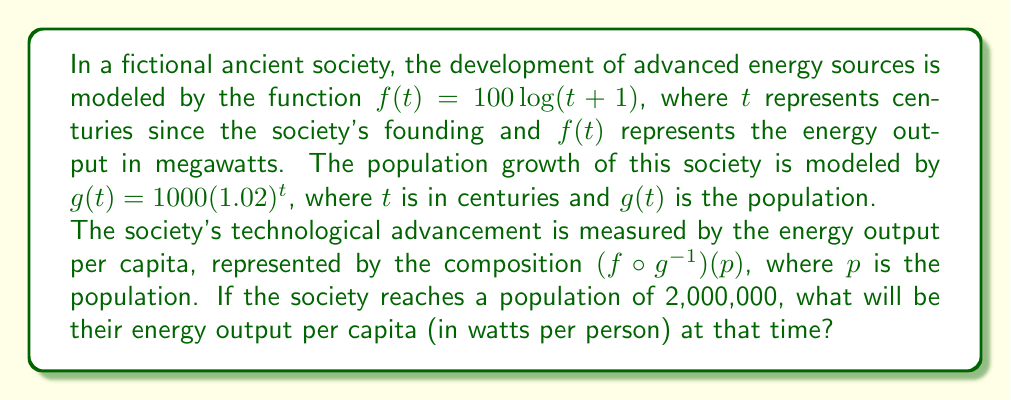Could you help me with this problem? Let's approach this step-by-step:

1) First, we need to find $g^{-1}(p)$. We start with:
   $g(t) = 1000(1.02)^t = p$

2) Solving for $t$:
   $1000(1.02)^t = p$
   $(1.02)^t = \frac{p}{1000}$
   $t = \log_{1.02}(\frac{p}{1000})$

   So, $g^{-1}(p) = \log_{1.02}(\frac{p}{1000})$

3) Now we can express $(f \circ g^{-1})(p)$:
   $(f \circ g^{-1})(p) = f(g^{-1}(p)) = 100\log(\log_{1.02}(\frac{p}{1000})+1)$

4) We're asked to find this value when $p = 2,000,000$. Let's substitute:
   $(f \circ g^{-1})(2,000,000) = 100\log(\log_{1.02}(\frac{2,000,000}{1000})+1)$
                                 $= 100\log(\log_{1.02}(2000)+1)$

5) Calculate $\log_{1.02}(2000)$:
   $\log_{1.02}(2000) \approx 384.2543$

6) Now we can finish the calculation:
   $100\log(384.2543+1) \approx 257.6945$

7) This result is in megawatts. To convert to watts per person, we divide by the population and multiply by 1,000,000:
   $\frac{257.6945 \times 1,000,000}{2,000,000} \approx 128.8473$ watts per person
Answer: Approximately 128.85 watts per person 